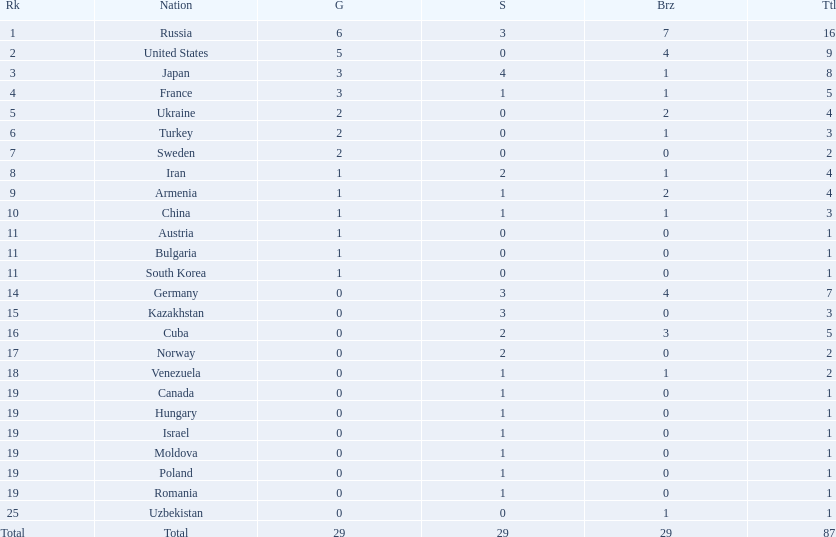How many countries competed? Israel. How many total medals did russia win? 16. What country won only 1 medal? Uzbekistan. 